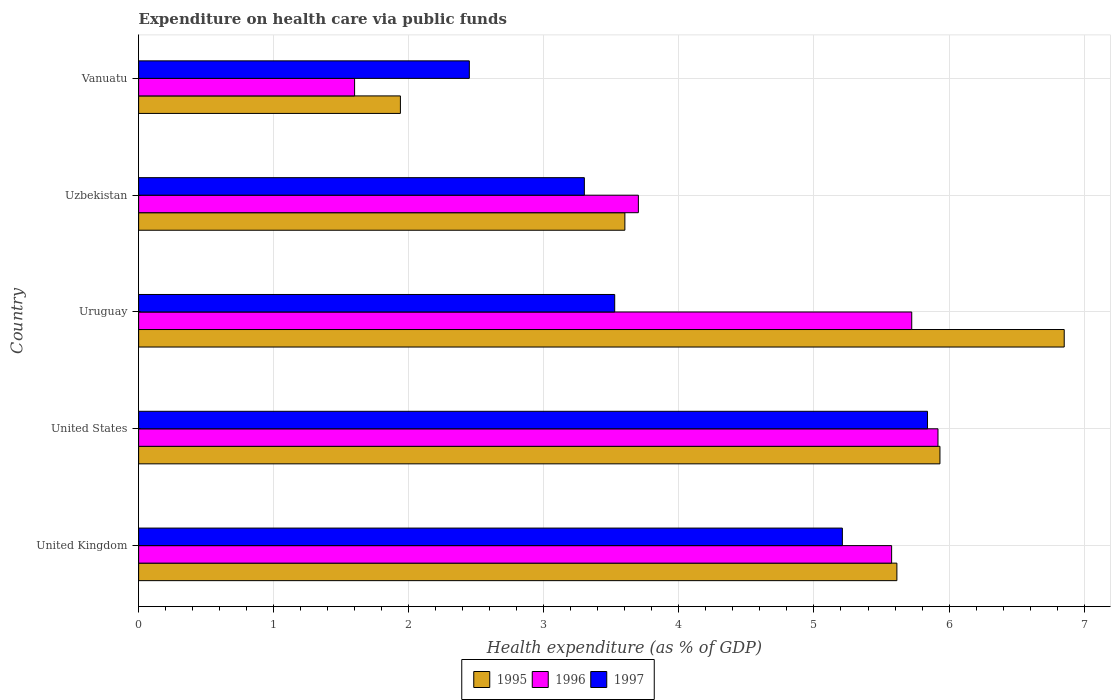How many different coloured bars are there?
Offer a terse response. 3. Are the number of bars on each tick of the Y-axis equal?
Ensure brevity in your answer.  Yes. How many bars are there on the 2nd tick from the bottom?
Your answer should be compact. 3. What is the label of the 3rd group of bars from the top?
Ensure brevity in your answer.  Uruguay. In how many cases, is the number of bars for a given country not equal to the number of legend labels?
Your answer should be very brief. 0. What is the expenditure made on health care in 1995 in United Kingdom?
Your response must be concise. 5.61. Across all countries, what is the maximum expenditure made on health care in 1996?
Provide a succinct answer. 5.92. Across all countries, what is the minimum expenditure made on health care in 1995?
Ensure brevity in your answer.  1.94. In which country was the expenditure made on health care in 1997 maximum?
Your answer should be very brief. United States. In which country was the expenditure made on health care in 1995 minimum?
Provide a short and direct response. Vanuatu. What is the total expenditure made on health care in 1997 in the graph?
Offer a terse response. 20.32. What is the difference between the expenditure made on health care in 1997 in Uzbekistan and that in Vanuatu?
Make the answer very short. 0.85. What is the difference between the expenditure made on health care in 1996 in United Kingdom and the expenditure made on health care in 1995 in United States?
Provide a short and direct response. -0.36. What is the average expenditure made on health care in 1997 per country?
Make the answer very short. 4.06. What is the difference between the expenditure made on health care in 1996 and expenditure made on health care in 1995 in Uzbekistan?
Keep it short and to the point. 0.1. What is the ratio of the expenditure made on health care in 1997 in United Kingdom to that in United States?
Provide a short and direct response. 0.89. What is the difference between the highest and the second highest expenditure made on health care in 1996?
Provide a succinct answer. 0.19. What is the difference between the highest and the lowest expenditure made on health care in 1996?
Your answer should be very brief. 4.32. In how many countries, is the expenditure made on health care in 1997 greater than the average expenditure made on health care in 1997 taken over all countries?
Make the answer very short. 2. Is the sum of the expenditure made on health care in 1996 in United States and Uzbekistan greater than the maximum expenditure made on health care in 1995 across all countries?
Give a very brief answer. Yes. What does the 2nd bar from the top in United States represents?
Provide a succinct answer. 1996. Is it the case that in every country, the sum of the expenditure made on health care in 1996 and expenditure made on health care in 1995 is greater than the expenditure made on health care in 1997?
Make the answer very short. Yes. How many bars are there?
Your answer should be compact. 15. Does the graph contain grids?
Ensure brevity in your answer.  Yes. Where does the legend appear in the graph?
Make the answer very short. Bottom center. What is the title of the graph?
Provide a succinct answer. Expenditure on health care via public funds. What is the label or title of the X-axis?
Provide a short and direct response. Health expenditure (as % of GDP). What is the label or title of the Y-axis?
Make the answer very short. Country. What is the Health expenditure (as % of GDP) of 1995 in United Kingdom?
Provide a succinct answer. 5.61. What is the Health expenditure (as % of GDP) of 1996 in United Kingdom?
Offer a very short reply. 5.57. What is the Health expenditure (as % of GDP) in 1997 in United Kingdom?
Provide a short and direct response. 5.21. What is the Health expenditure (as % of GDP) of 1995 in United States?
Your answer should be compact. 5.93. What is the Health expenditure (as % of GDP) in 1996 in United States?
Provide a short and direct response. 5.92. What is the Health expenditure (as % of GDP) of 1997 in United States?
Keep it short and to the point. 5.84. What is the Health expenditure (as % of GDP) in 1995 in Uruguay?
Give a very brief answer. 6.85. What is the Health expenditure (as % of GDP) in 1996 in Uruguay?
Offer a terse response. 5.72. What is the Health expenditure (as % of GDP) in 1997 in Uruguay?
Give a very brief answer. 3.52. What is the Health expenditure (as % of GDP) of 1995 in Uzbekistan?
Give a very brief answer. 3.6. What is the Health expenditure (as % of GDP) in 1996 in Uzbekistan?
Give a very brief answer. 3.7. What is the Health expenditure (as % of GDP) of 1997 in Uzbekistan?
Provide a succinct answer. 3.3. What is the Health expenditure (as % of GDP) of 1995 in Vanuatu?
Offer a terse response. 1.94. What is the Health expenditure (as % of GDP) of 1996 in Vanuatu?
Offer a terse response. 1.6. What is the Health expenditure (as % of GDP) of 1997 in Vanuatu?
Offer a terse response. 2.45. Across all countries, what is the maximum Health expenditure (as % of GDP) of 1995?
Provide a short and direct response. 6.85. Across all countries, what is the maximum Health expenditure (as % of GDP) of 1996?
Your answer should be very brief. 5.92. Across all countries, what is the maximum Health expenditure (as % of GDP) of 1997?
Offer a terse response. 5.84. Across all countries, what is the minimum Health expenditure (as % of GDP) in 1995?
Keep it short and to the point. 1.94. Across all countries, what is the minimum Health expenditure (as % of GDP) of 1996?
Your answer should be compact. 1.6. Across all countries, what is the minimum Health expenditure (as % of GDP) of 1997?
Provide a succinct answer. 2.45. What is the total Health expenditure (as % of GDP) in 1995 in the graph?
Give a very brief answer. 23.94. What is the total Health expenditure (as % of GDP) of 1996 in the graph?
Your response must be concise. 22.52. What is the total Health expenditure (as % of GDP) in 1997 in the graph?
Make the answer very short. 20.32. What is the difference between the Health expenditure (as % of GDP) in 1995 in United Kingdom and that in United States?
Offer a very short reply. -0.32. What is the difference between the Health expenditure (as % of GDP) in 1996 in United Kingdom and that in United States?
Offer a very short reply. -0.34. What is the difference between the Health expenditure (as % of GDP) of 1997 in United Kingdom and that in United States?
Make the answer very short. -0.63. What is the difference between the Health expenditure (as % of GDP) in 1995 in United Kingdom and that in Uruguay?
Offer a terse response. -1.24. What is the difference between the Health expenditure (as % of GDP) of 1996 in United Kingdom and that in Uruguay?
Make the answer very short. -0.15. What is the difference between the Health expenditure (as % of GDP) in 1997 in United Kingdom and that in Uruguay?
Your response must be concise. 1.69. What is the difference between the Health expenditure (as % of GDP) of 1995 in United Kingdom and that in Uzbekistan?
Offer a terse response. 2.01. What is the difference between the Health expenditure (as % of GDP) in 1996 in United Kingdom and that in Uzbekistan?
Your answer should be very brief. 1.87. What is the difference between the Health expenditure (as % of GDP) of 1997 in United Kingdom and that in Uzbekistan?
Your response must be concise. 1.91. What is the difference between the Health expenditure (as % of GDP) in 1995 in United Kingdom and that in Vanuatu?
Your answer should be very brief. 3.68. What is the difference between the Health expenditure (as % of GDP) of 1996 in United Kingdom and that in Vanuatu?
Ensure brevity in your answer.  3.98. What is the difference between the Health expenditure (as % of GDP) in 1997 in United Kingdom and that in Vanuatu?
Offer a terse response. 2.76. What is the difference between the Health expenditure (as % of GDP) of 1995 in United States and that in Uruguay?
Offer a terse response. -0.92. What is the difference between the Health expenditure (as % of GDP) of 1996 in United States and that in Uruguay?
Your answer should be compact. 0.19. What is the difference between the Health expenditure (as % of GDP) in 1997 in United States and that in Uruguay?
Provide a short and direct response. 2.32. What is the difference between the Health expenditure (as % of GDP) of 1995 in United States and that in Uzbekistan?
Keep it short and to the point. 2.33. What is the difference between the Health expenditure (as % of GDP) of 1996 in United States and that in Uzbekistan?
Give a very brief answer. 2.22. What is the difference between the Health expenditure (as % of GDP) of 1997 in United States and that in Uzbekistan?
Provide a short and direct response. 2.54. What is the difference between the Health expenditure (as % of GDP) in 1995 in United States and that in Vanuatu?
Provide a succinct answer. 3.99. What is the difference between the Health expenditure (as % of GDP) of 1996 in United States and that in Vanuatu?
Make the answer very short. 4.32. What is the difference between the Health expenditure (as % of GDP) of 1997 in United States and that in Vanuatu?
Offer a very short reply. 3.39. What is the difference between the Health expenditure (as % of GDP) of 1995 in Uruguay and that in Uzbekistan?
Your answer should be very brief. 3.25. What is the difference between the Health expenditure (as % of GDP) of 1996 in Uruguay and that in Uzbekistan?
Make the answer very short. 2.02. What is the difference between the Health expenditure (as % of GDP) in 1997 in Uruguay and that in Uzbekistan?
Provide a succinct answer. 0.22. What is the difference between the Health expenditure (as % of GDP) of 1995 in Uruguay and that in Vanuatu?
Offer a very short reply. 4.91. What is the difference between the Health expenditure (as % of GDP) of 1996 in Uruguay and that in Vanuatu?
Ensure brevity in your answer.  4.12. What is the difference between the Health expenditure (as % of GDP) in 1997 in Uruguay and that in Vanuatu?
Ensure brevity in your answer.  1.08. What is the difference between the Health expenditure (as % of GDP) of 1995 in Uzbekistan and that in Vanuatu?
Your response must be concise. 1.66. What is the difference between the Health expenditure (as % of GDP) in 1996 in Uzbekistan and that in Vanuatu?
Your answer should be very brief. 2.1. What is the difference between the Health expenditure (as % of GDP) of 1997 in Uzbekistan and that in Vanuatu?
Offer a very short reply. 0.85. What is the difference between the Health expenditure (as % of GDP) in 1995 in United Kingdom and the Health expenditure (as % of GDP) in 1996 in United States?
Give a very brief answer. -0.3. What is the difference between the Health expenditure (as % of GDP) in 1995 in United Kingdom and the Health expenditure (as % of GDP) in 1997 in United States?
Provide a succinct answer. -0.23. What is the difference between the Health expenditure (as % of GDP) in 1996 in United Kingdom and the Health expenditure (as % of GDP) in 1997 in United States?
Give a very brief answer. -0.27. What is the difference between the Health expenditure (as % of GDP) in 1995 in United Kingdom and the Health expenditure (as % of GDP) in 1996 in Uruguay?
Make the answer very short. -0.11. What is the difference between the Health expenditure (as % of GDP) of 1995 in United Kingdom and the Health expenditure (as % of GDP) of 1997 in Uruguay?
Your answer should be compact. 2.09. What is the difference between the Health expenditure (as % of GDP) of 1996 in United Kingdom and the Health expenditure (as % of GDP) of 1997 in Uruguay?
Give a very brief answer. 2.05. What is the difference between the Health expenditure (as % of GDP) in 1995 in United Kingdom and the Health expenditure (as % of GDP) in 1996 in Uzbekistan?
Provide a short and direct response. 1.91. What is the difference between the Health expenditure (as % of GDP) of 1995 in United Kingdom and the Health expenditure (as % of GDP) of 1997 in Uzbekistan?
Provide a short and direct response. 2.31. What is the difference between the Health expenditure (as % of GDP) of 1996 in United Kingdom and the Health expenditure (as % of GDP) of 1997 in Uzbekistan?
Provide a short and direct response. 2.27. What is the difference between the Health expenditure (as % of GDP) of 1995 in United Kingdom and the Health expenditure (as % of GDP) of 1996 in Vanuatu?
Your answer should be very brief. 4.01. What is the difference between the Health expenditure (as % of GDP) in 1995 in United Kingdom and the Health expenditure (as % of GDP) in 1997 in Vanuatu?
Your answer should be very brief. 3.17. What is the difference between the Health expenditure (as % of GDP) in 1996 in United Kingdom and the Health expenditure (as % of GDP) in 1997 in Vanuatu?
Your answer should be compact. 3.13. What is the difference between the Health expenditure (as % of GDP) of 1995 in United States and the Health expenditure (as % of GDP) of 1996 in Uruguay?
Your response must be concise. 0.21. What is the difference between the Health expenditure (as % of GDP) in 1995 in United States and the Health expenditure (as % of GDP) in 1997 in Uruguay?
Your response must be concise. 2.41. What is the difference between the Health expenditure (as % of GDP) of 1996 in United States and the Health expenditure (as % of GDP) of 1997 in Uruguay?
Provide a succinct answer. 2.39. What is the difference between the Health expenditure (as % of GDP) of 1995 in United States and the Health expenditure (as % of GDP) of 1996 in Uzbekistan?
Make the answer very short. 2.23. What is the difference between the Health expenditure (as % of GDP) of 1995 in United States and the Health expenditure (as % of GDP) of 1997 in Uzbekistan?
Provide a short and direct response. 2.63. What is the difference between the Health expenditure (as % of GDP) in 1996 in United States and the Health expenditure (as % of GDP) in 1997 in Uzbekistan?
Offer a terse response. 2.62. What is the difference between the Health expenditure (as % of GDP) in 1995 in United States and the Health expenditure (as % of GDP) in 1996 in Vanuatu?
Keep it short and to the point. 4.33. What is the difference between the Health expenditure (as % of GDP) in 1995 in United States and the Health expenditure (as % of GDP) in 1997 in Vanuatu?
Make the answer very short. 3.48. What is the difference between the Health expenditure (as % of GDP) in 1996 in United States and the Health expenditure (as % of GDP) in 1997 in Vanuatu?
Provide a succinct answer. 3.47. What is the difference between the Health expenditure (as % of GDP) of 1995 in Uruguay and the Health expenditure (as % of GDP) of 1996 in Uzbekistan?
Ensure brevity in your answer.  3.15. What is the difference between the Health expenditure (as % of GDP) in 1995 in Uruguay and the Health expenditure (as % of GDP) in 1997 in Uzbekistan?
Give a very brief answer. 3.55. What is the difference between the Health expenditure (as % of GDP) in 1996 in Uruguay and the Health expenditure (as % of GDP) in 1997 in Uzbekistan?
Offer a very short reply. 2.42. What is the difference between the Health expenditure (as % of GDP) in 1995 in Uruguay and the Health expenditure (as % of GDP) in 1996 in Vanuatu?
Your response must be concise. 5.25. What is the difference between the Health expenditure (as % of GDP) in 1995 in Uruguay and the Health expenditure (as % of GDP) in 1997 in Vanuatu?
Keep it short and to the point. 4.4. What is the difference between the Health expenditure (as % of GDP) of 1996 in Uruguay and the Health expenditure (as % of GDP) of 1997 in Vanuatu?
Give a very brief answer. 3.28. What is the difference between the Health expenditure (as % of GDP) in 1995 in Uzbekistan and the Health expenditure (as % of GDP) in 1996 in Vanuatu?
Ensure brevity in your answer.  2. What is the difference between the Health expenditure (as % of GDP) in 1995 in Uzbekistan and the Health expenditure (as % of GDP) in 1997 in Vanuatu?
Make the answer very short. 1.15. What is the difference between the Health expenditure (as % of GDP) in 1996 in Uzbekistan and the Health expenditure (as % of GDP) in 1997 in Vanuatu?
Ensure brevity in your answer.  1.25. What is the average Health expenditure (as % of GDP) of 1995 per country?
Ensure brevity in your answer.  4.79. What is the average Health expenditure (as % of GDP) in 1996 per country?
Keep it short and to the point. 4.5. What is the average Health expenditure (as % of GDP) in 1997 per country?
Make the answer very short. 4.06. What is the difference between the Health expenditure (as % of GDP) of 1995 and Health expenditure (as % of GDP) of 1996 in United Kingdom?
Offer a terse response. 0.04. What is the difference between the Health expenditure (as % of GDP) of 1995 and Health expenditure (as % of GDP) of 1997 in United Kingdom?
Offer a terse response. 0.4. What is the difference between the Health expenditure (as % of GDP) of 1996 and Health expenditure (as % of GDP) of 1997 in United Kingdom?
Make the answer very short. 0.36. What is the difference between the Health expenditure (as % of GDP) of 1995 and Health expenditure (as % of GDP) of 1996 in United States?
Ensure brevity in your answer.  0.01. What is the difference between the Health expenditure (as % of GDP) in 1995 and Health expenditure (as % of GDP) in 1997 in United States?
Provide a short and direct response. 0.09. What is the difference between the Health expenditure (as % of GDP) of 1996 and Health expenditure (as % of GDP) of 1997 in United States?
Offer a very short reply. 0.08. What is the difference between the Health expenditure (as % of GDP) in 1995 and Health expenditure (as % of GDP) in 1996 in Uruguay?
Offer a terse response. 1.13. What is the difference between the Health expenditure (as % of GDP) of 1995 and Health expenditure (as % of GDP) of 1997 in Uruguay?
Your answer should be very brief. 3.33. What is the difference between the Health expenditure (as % of GDP) in 1996 and Health expenditure (as % of GDP) in 1997 in Uruguay?
Make the answer very short. 2.2. What is the difference between the Health expenditure (as % of GDP) of 1995 and Health expenditure (as % of GDP) of 1996 in Uzbekistan?
Offer a terse response. -0.1. What is the difference between the Health expenditure (as % of GDP) of 1995 and Health expenditure (as % of GDP) of 1997 in Uzbekistan?
Keep it short and to the point. 0.3. What is the difference between the Health expenditure (as % of GDP) in 1996 and Health expenditure (as % of GDP) in 1997 in Uzbekistan?
Offer a terse response. 0.4. What is the difference between the Health expenditure (as % of GDP) in 1995 and Health expenditure (as % of GDP) in 1996 in Vanuatu?
Offer a terse response. 0.34. What is the difference between the Health expenditure (as % of GDP) of 1995 and Health expenditure (as % of GDP) of 1997 in Vanuatu?
Make the answer very short. -0.51. What is the difference between the Health expenditure (as % of GDP) in 1996 and Health expenditure (as % of GDP) in 1997 in Vanuatu?
Offer a very short reply. -0.85. What is the ratio of the Health expenditure (as % of GDP) in 1995 in United Kingdom to that in United States?
Offer a very short reply. 0.95. What is the ratio of the Health expenditure (as % of GDP) in 1996 in United Kingdom to that in United States?
Make the answer very short. 0.94. What is the ratio of the Health expenditure (as % of GDP) of 1997 in United Kingdom to that in United States?
Your response must be concise. 0.89. What is the ratio of the Health expenditure (as % of GDP) in 1995 in United Kingdom to that in Uruguay?
Provide a succinct answer. 0.82. What is the ratio of the Health expenditure (as % of GDP) of 1997 in United Kingdom to that in Uruguay?
Make the answer very short. 1.48. What is the ratio of the Health expenditure (as % of GDP) in 1995 in United Kingdom to that in Uzbekistan?
Your response must be concise. 1.56. What is the ratio of the Health expenditure (as % of GDP) in 1996 in United Kingdom to that in Uzbekistan?
Ensure brevity in your answer.  1.51. What is the ratio of the Health expenditure (as % of GDP) in 1997 in United Kingdom to that in Uzbekistan?
Your answer should be compact. 1.58. What is the ratio of the Health expenditure (as % of GDP) of 1995 in United Kingdom to that in Vanuatu?
Your answer should be compact. 2.9. What is the ratio of the Health expenditure (as % of GDP) of 1996 in United Kingdom to that in Vanuatu?
Ensure brevity in your answer.  3.49. What is the ratio of the Health expenditure (as % of GDP) in 1997 in United Kingdom to that in Vanuatu?
Your answer should be very brief. 2.13. What is the ratio of the Health expenditure (as % of GDP) of 1995 in United States to that in Uruguay?
Your answer should be compact. 0.87. What is the ratio of the Health expenditure (as % of GDP) of 1996 in United States to that in Uruguay?
Your answer should be compact. 1.03. What is the ratio of the Health expenditure (as % of GDP) in 1997 in United States to that in Uruguay?
Your response must be concise. 1.66. What is the ratio of the Health expenditure (as % of GDP) of 1995 in United States to that in Uzbekistan?
Provide a succinct answer. 1.65. What is the ratio of the Health expenditure (as % of GDP) of 1996 in United States to that in Uzbekistan?
Give a very brief answer. 1.6. What is the ratio of the Health expenditure (as % of GDP) in 1997 in United States to that in Uzbekistan?
Give a very brief answer. 1.77. What is the ratio of the Health expenditure (as % of GDP) of 1995 in United States to that in Vanuatu?
Your answer should be compact. 3.06. What is the ratio of the Health expenditure (as % of GDP) of 1996 in United States to that in Vanuatu?
Offer a very short reply. 3.7. What is the ratio of the Health expenditure (as % of GDP) in 1997 in United States to that in Vanuatu?
Your answer should be very brief. 2.39. What is the ratio of the Health expenditure (as % of GDP) in 1995 in Uruguay to that in Uzbekistan?
Offer a terse response. 1.9. What is the ratio of the Health expenditure (as % of GDP) in 1996 in Uruguay to that in Uzbekistan?
Offer a very short reply. 1.55. What is the ratio of the Health expenditure (as % of GDP) of 1997 in Uruguay to that in Uzbekistan?
Give a very brief answer. 1.07. What is the ratio of the Health expenditure (as % of GDP) of 1995 in Uruguay to that in Vanuatu?
Your answer should be compact. 3.54. What is the ratio of the Health expenditure (as % of GDP) of 1996 in Uruguay to that in Vanuatu?
Offer a very short reply. 3.58. What is the ratio of the Health expenditure (as % of GDP) of 1997 in Uruguay to that in Vanuatu?
Ensure brevity in your answer.  1.44. What is the ratio of the Health expenditure (as % of GDP) of 1995 in Uzbekistan to that in Vanuatu?
Provide a short and direct response. 1.86. What is the ratio of the Health expenditure (as % of GDP) of 1996 in Uzbekistan to that in Vanuatu?
Make the answer very short. 2.31. What is the ratio of the Health expenditure (as % of GDP) in 1997 in Uzbekistan to that in Vanuatu?
Keep it short and to the point. 1.35. What is the difference between the highest and the second highest Health expenditure (as % of GDP) in 1996?
Your answer should be compact. 0.19. What is the difference between the highest and the second highest Health expenditure (as % of GDP) of 1997?
Your answer should be very brief. 0.63. What is the difference between the highest and the lowest Health expenditure (as % of GDP) of 1995?
Make the answer very short. 4.91. What is the difference between the highest and the lowest Health expenditure (as % of GDP) in 1996?
Make the answer very short. 4.32. What is the difference between the highest and the lowest Health expenditure (as % of GDP) in 1997?
Give a very brief answer. 3.39. 